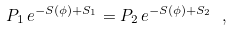<formula> <loc_0><loc_0><loc_500><loc_500>P _ { 1 } \, e ^ { - S ( \phi ) + S _ { 1 } } = P _ { 2 } \, e ^ { - S ( \phi ) + S _ { 2 } } \ ,</formula> 